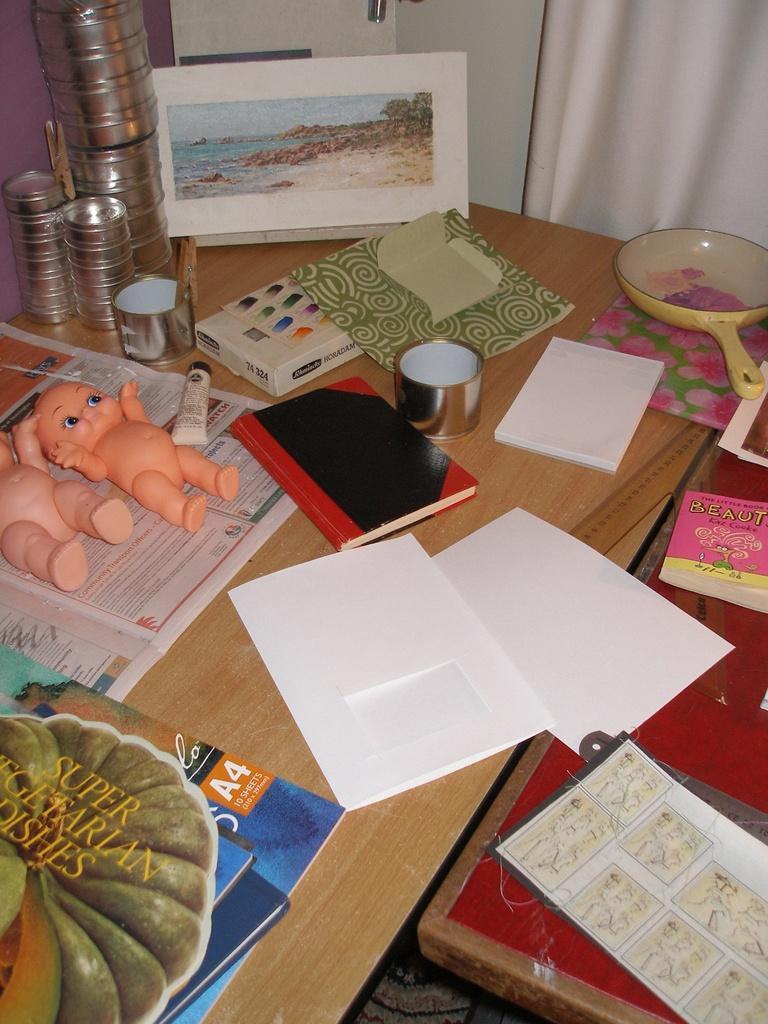How would you summarize this image in a sentence or two? In this picture we can see there are two tables and on the tables there are papers, books, dolls, pan, steel items and other objects. Behind the table, it looks like a wall and a curtain. 